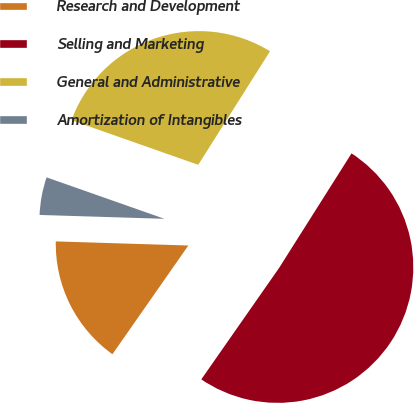Convert chart. <chart><loc_0><loc_0><loc_500><loc_500><pie_chart><fcel>Research and Development<fcel>Selling and Marketing<fcel>General and Administrative<fcel>Amortization of Intangibles<nl><fcel>15.79%<fcel>50.72%<fcel>28.59%<fcel>4.89%<nl></chart> 